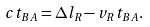Convert formula to latex. <formula><loc_0><loc_0><loc_500><loc_500>c t _ { B A } = \Delta l _ { R } - v _ { R } t _ { B A } .</formula> 